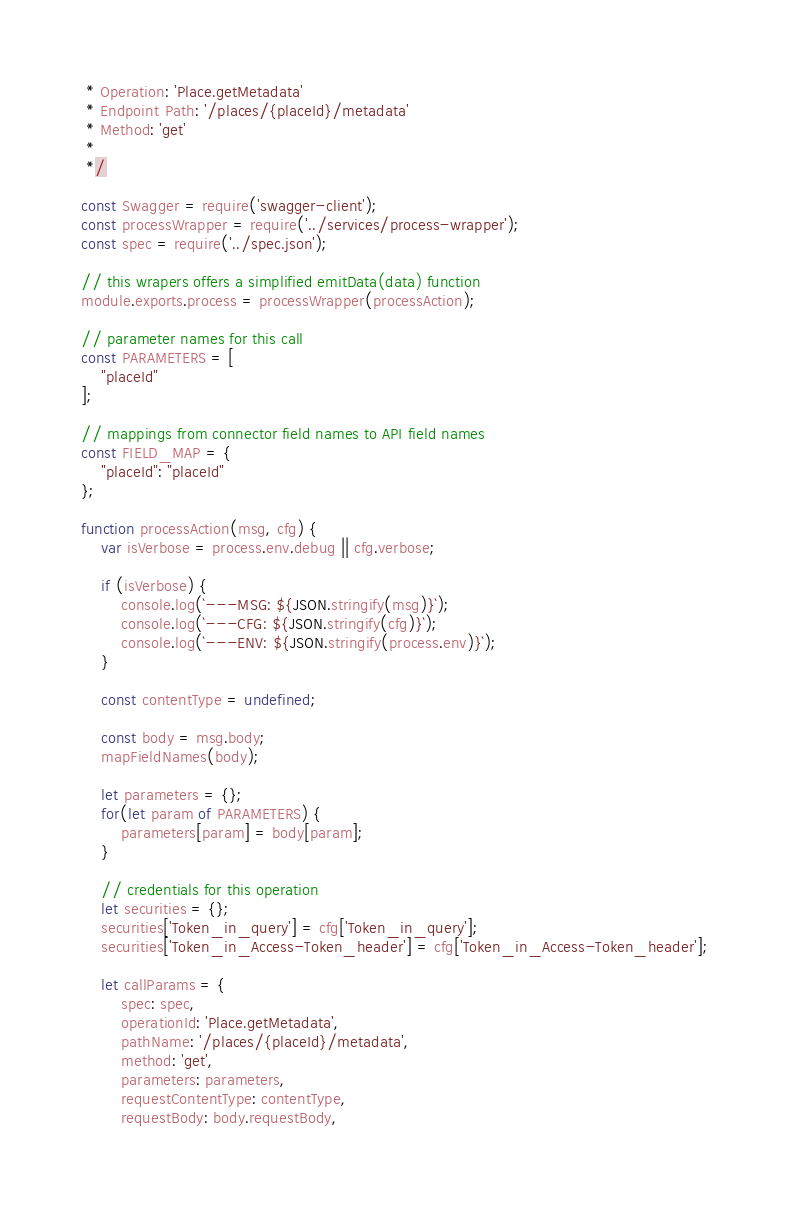<code> <loc_0><loc_0><loc_500><loc_500><_JavaScript_> * Operation: 'Place.getMetadata'
 * Endpoint Path: '/places/{placeId}/metadata'
 * Method: 'get'
 *
 */

const Swagger = require('swagger-client');
const processWrapper = require('../services/process-wrapper');
const spec = require('../spec.json');

// this wrapers offers a simplified emitData(data) function
module.exports.process = processWrapper(processAction);

// parameter names for this call
const PARAMETERS = [
    "placeId"
];

// mappings from connector field names to API field names
const FIELD_MAP = {
    "placeId": "placeId"
};

function processAction(msg, cfg) {
    var isVerbose = process.env.debug || cfg.verbose;

    if (isVerbose) {
        console.log(`---MSG: ${JSON.stringify(msg)}`);
        console.log(`---CFG: ${JSON.stringify(cfg)}`);
        console.log(`---ENV: ${JSON.stringify(process.env)}`);
    }

    const contentType = undefined;

    const body = msg.body;
    mapFieldNames(body);

    let parameters = {};
    for(let param of PARAMETERS) {
        parameters[param] = body[param];
    }

    // credentials for this operation
    let securities = {};
    securities['Token_in_query'] = cfg['Token_in_query'];
    securities['Token_in_Access-Token_header'] = cfg['Token_in_Access-Token_header'];

    let callParams = {
        spec: spec,
        operationId: 'Place.getMetadata',
        pathName: '/places/{placeId}/metadata',
        method: 'get',
        parameters: parameters,
        requestContentType: contentType,
        requestBody: body.requestBody,</code> 